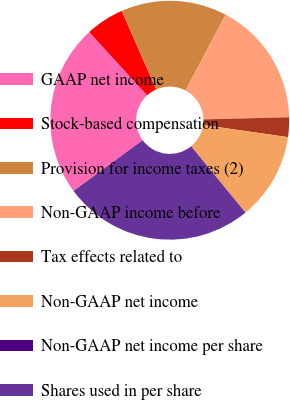Convert chart. <chart><loc_0><loc_0><loc_500><loc_500><pie_chart><fcel>GAAP net income<fcel>Stock-based compensation<fcel>Provision for income taxes (2)<fcel>Non-GAAP income before<fcel>Tax effects related to<fcel>Non-GAAP net income<fcel>Non-GAAP net income per share<fcel>Shares used in per share<nl><fcel>23.31%<fcel>5.19%<fcel>14.33%<fcel>16.86%<fcel>2.66%<fcel>11.81%<fcel>0.0%<fcel>25.84%<nl></chart> 